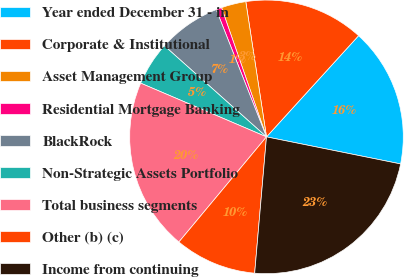Convert chart. <chart><loc_0><loc_0><loc_500><loc_500><pie_chart><fcel>Year ended December 31 - in<fcel>Corporate & Institutional<fcel>Asset Management Group<fcel>Residential Mortgage Banking<fcel>BlackRock<fcel>Non-Strategic Assets Portfolio<fcel>Total business segments<fcel>Other (b) (c)<fcel>Income from continuing<nl><fcel>16.42%<fcel>14.17%<fcel>2.91%<fcel>0.66%<fcel>7.42%<fcel>5.17%<fcel>20.37%<fcel>9.68%<fcel>23.21%<nl></chart> 